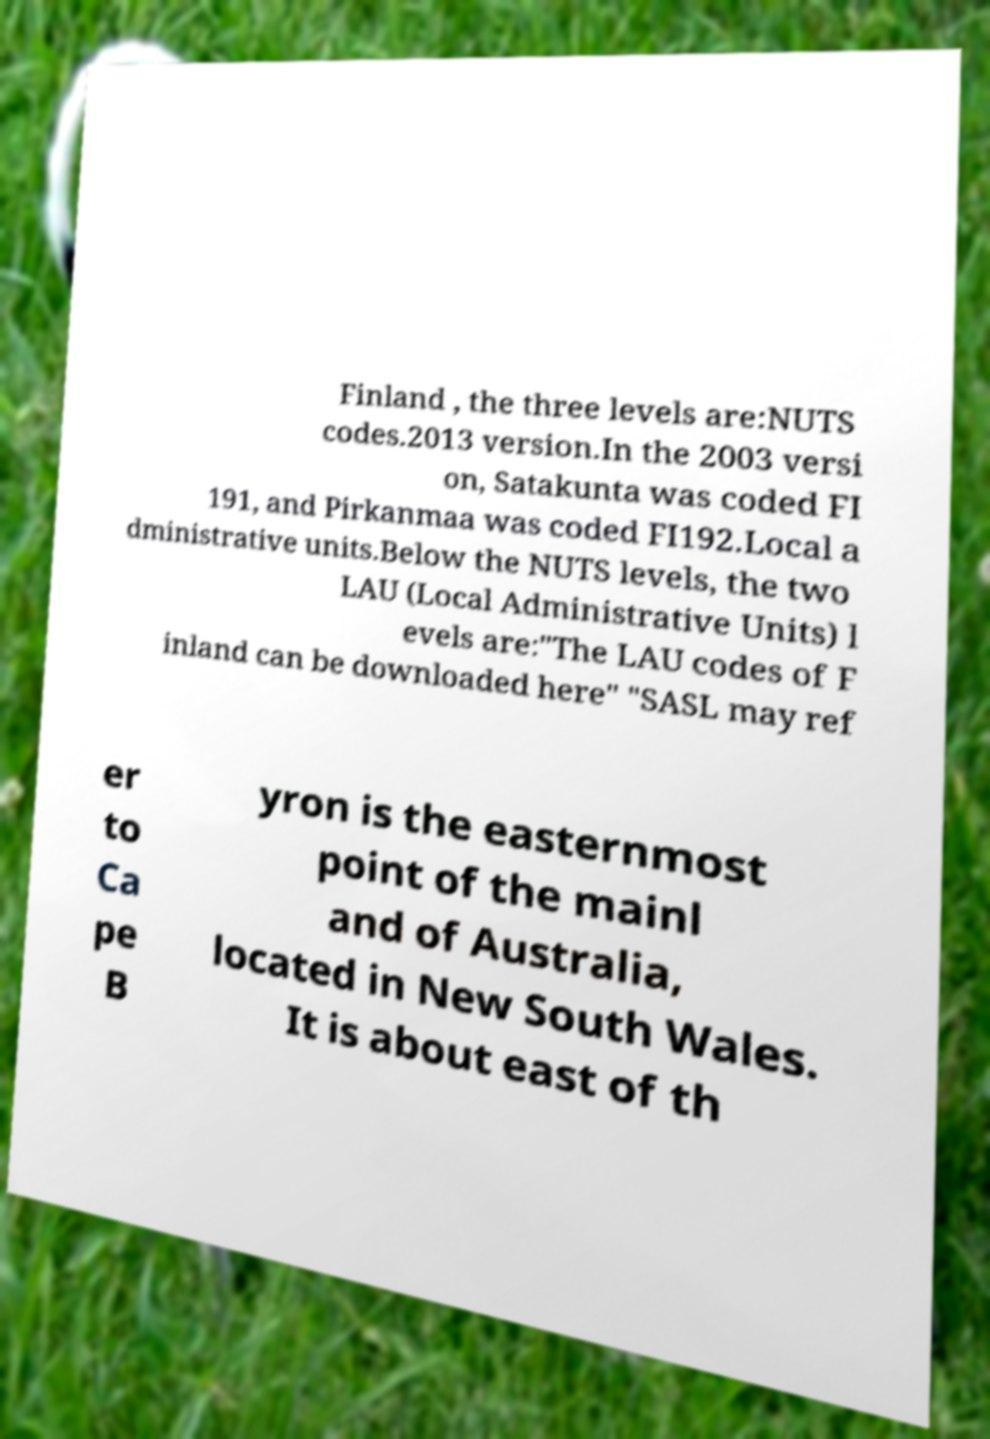I need the written content from this picture converted into text. Can you do that? Finland , the three levels are:NUTS codes.2013 version.In the 2003 versi on, Satakunta was coded FI 191, and Pirkanmaa was coded FI192.Local a dministrative units.Below the NUTS levels, the two LAU (Local Administrative Units) l evels are:"The LAU codes of F inland can be downloaded here" "SASL may ref er to Ca pe B yron is the easternmost point of the mainl and of Australia, located in New South Wales. It is about east of th 